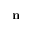Convert formula to latex. <formula><loc_0><loc_0><loc_500><loc_500>n</formula> 